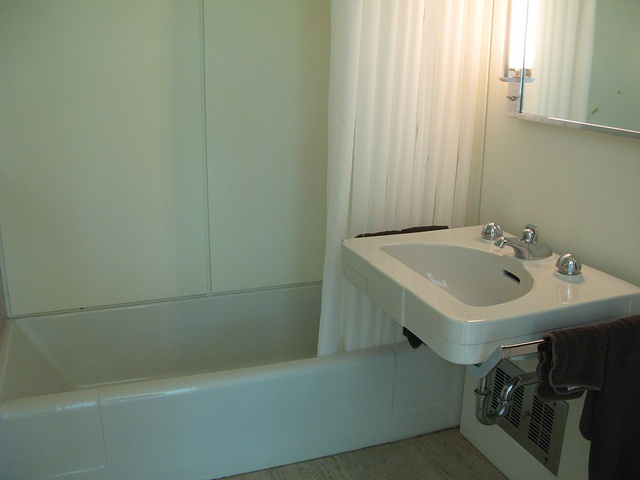Describe the objects in this image and their specific colors. I can see a sink in gray and darkgray tones in this image. 